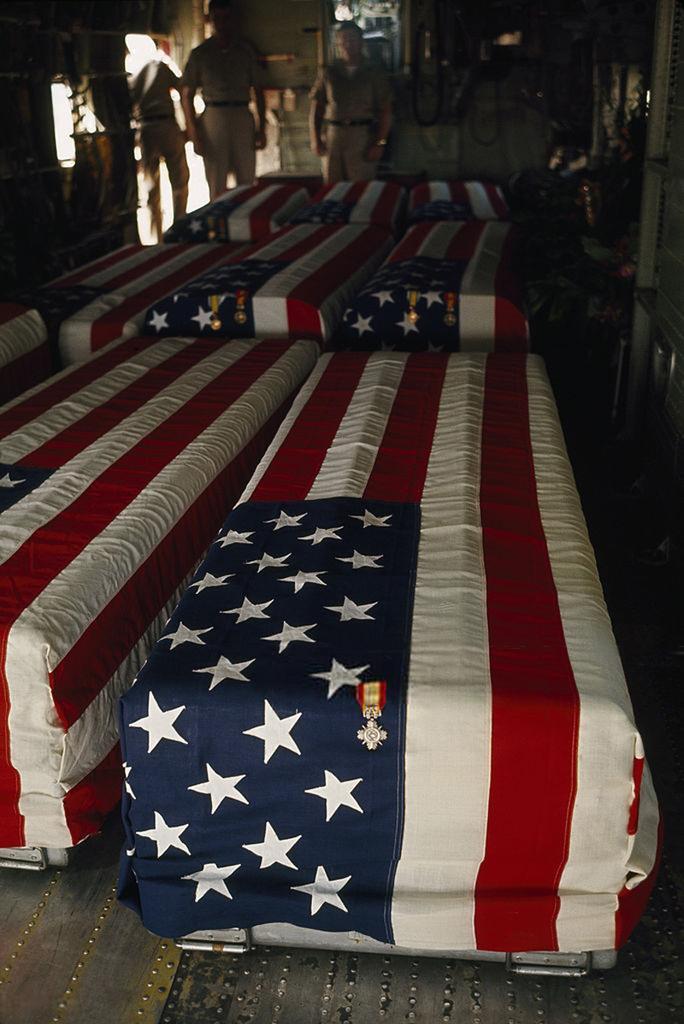Describe this image in one or two sentences. In this image I can see few boxes covered with flags. In the background I can see group of people standing. 